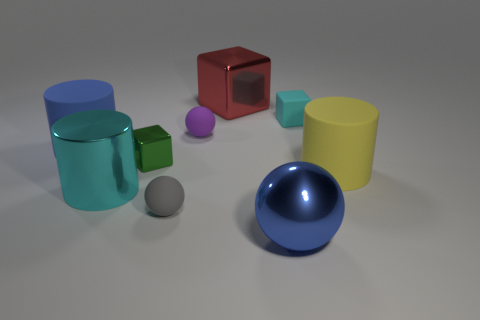What material is the object that is in front of the small sphere that is in front of the big matte cylinder on the left side of the cyan rubber block?
Give a very brief answer. Metal. The metal sphere has what color?
Keep it short and to the point. Blue. What number of small objects are either blue objects or yellow rubber cylinders?
Your answer should be very brief. 0. There is a big thing that is the same color as the big sphere; what is its material?
Provide a short and direct response. Rubber. Is the material of the ball that is right of the big red metal object the same as the small block behind the green thing?
Offer a very short reply. No. Are any big green objects visible?
Your answer should be very brief. No. Is the number of large objects that are in front of the gray rubber ball greater than the number of small purple things that are left of the big cyan object?
Your answer should be compact. Yes. There is a tiny green thing that is the same shape as the big red object; what is its material?
Provide a short and direct response. Metal. There is a matte cylinder left of the red thing; does it have the same color as the big matte cylinder that is in front of the tiny green object?
Your response must be concise. No. The yellow thing is what shape?
Your response must be concise. Cylinder. 